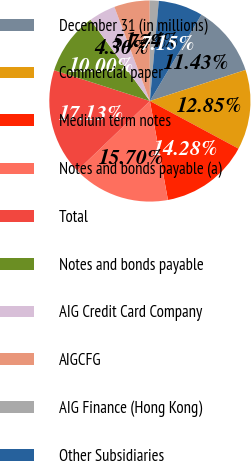<chart> <loc_0><loc_0><loc_500><loc_500><pie_chart><fcel>December 31 (in millions)<fcel>Commercial paper<fcel>Medium term notes<fcel>Notes and bonds payable (a)<fcel>Total<fcel>Notes and bonds payable<fcel>AIG Credit Card Company<fcel>AIGCFG<fcel>AIG Finance (Hong Kong)<fcel>Other Subsidiaries<nl><fcel>11.43%<fcel>12.85%<fcel>14.28%<fcel>15.7%<fcel>17.13%<fcel>10.0%<fcel>4.3%<fcel>5.72%<fcel>1.44%<fcel>7.15%<nl></chart> 